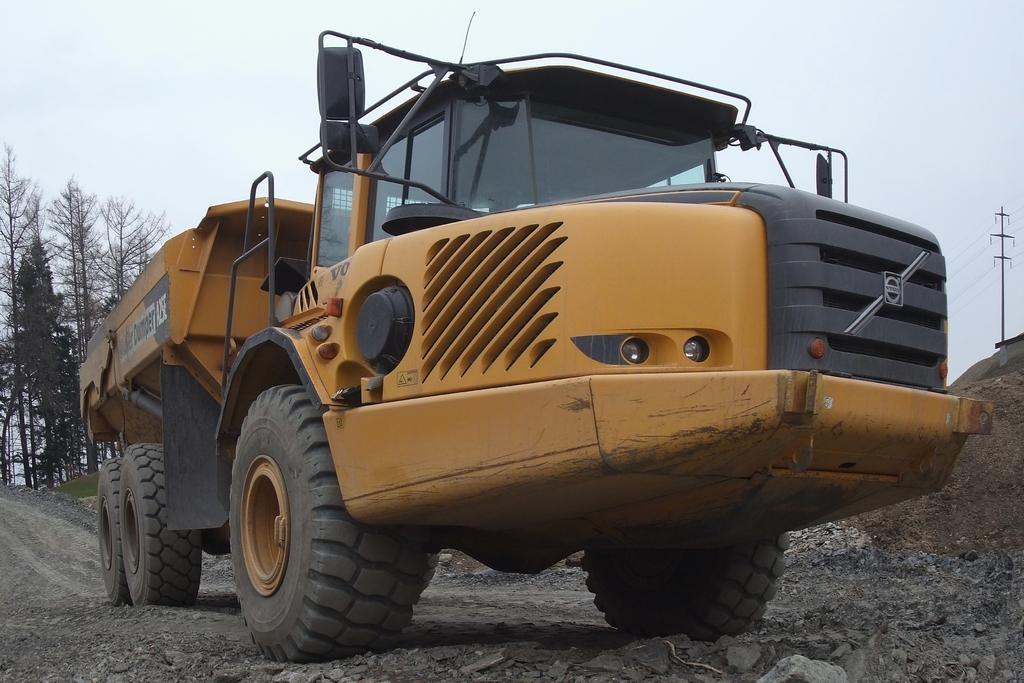Please provide a concise description of this image. This image is taken outdoors. At the top of the image there is the sky. In the background there are a few trees on the ground. On the right side of the image there is a pole with a few wires. At the bottom of the image there is a ground. In the middle of the image a vehicle is parked on the ground. The vehicle is yellow in color. 